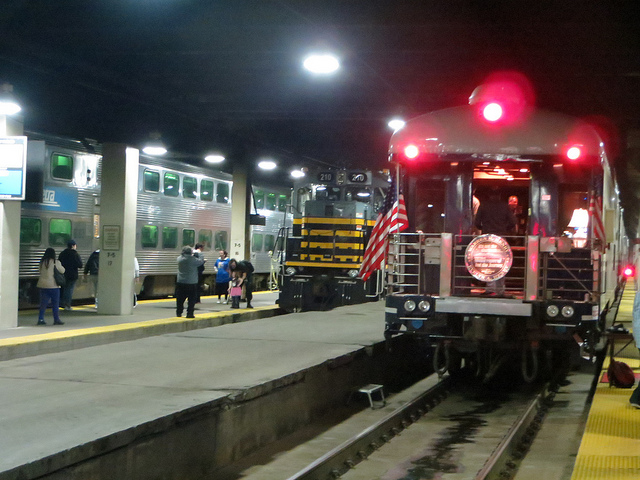Please identify all text content in this image. 210 